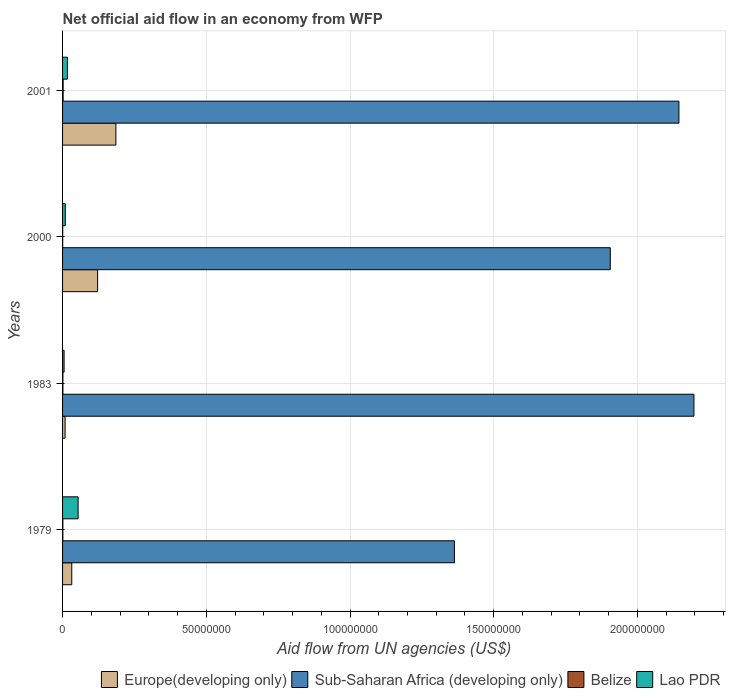How many different coloured bars are there?
Your response must be concise. 4. How many bars are there on the 1st tick from the bottom?
Your answer should be very brief. 4. What is the label of the 3rd group of bars from the top?
Your answer should be very brief. 1983. In how many cases, is the number of bars for a given year not equal to the number of legend labels?
Your answer should be compact. 0. Across all years, what is the maximum net official aid flow in Lao PDR?
Your answer should be very brief. 5.41e+06. In which year was the net official aid flow in Europe(developing only) maximum?
Provide a short and direct response. 2001. What is the total net official aid flow in Sub-Saharan Africa (developing only) in the graph?
Give a very brief answer. 7.61e+08. What is the difference between the net official aid flow in Lao PDR in 1979 and the net official aid flow in Sub-Saharan Africa (developing only) in 2000?
Keep it short and to the point. -1.85e+08. What is the average net official aid flow in Belize per year?
Your answer should be compact. 1.18e+05. In the year 2000, what is the difference between the net official aid flow in Lao PDR and net official aid flow in Sub-Saharan Africa (developing only)?
Provide a succinct answer. -1.90e+08. In how many years, is the net official aid flow in Lao PDR greater than 60000000 US$?
Make the answer very short. 0. What is the ratio of the net official aid flow in Europe(developing only) in 1979 to that in 1983?
Your answer should be compact. 3.64. Is the net official aid flow in Europe(developing only) in 1979 less than that in 1983?
Offer a very short reply. No. Is the difference between the net official aid flow in Lao PDR in 1979 and 2001 greater than the difference between the net official aid flow in Sub-Saharan Africa (developing only) in 1979 and 2001?
Offer a very short reply. Yes. What is the difference between the highest and the second highest net official aid flow in Belize?
Offer a terse response. 8.00e+04. What is the difference between the highest and the lowest net official aid flow in Lao PDR?
Keep it short and to the point. 4.88e+06. In how many years, is the net official aid flow in Belize greater than the average net official aid flow in Belize taken over all years?
Provide a short and direct response. 2. What does the 1st bar from the top in 1983 represents?
Your response must be concise. Lao PDR. What does the 1st bar from the bottom in 1979 represents?
Provide a succinct answer. Europe(developing only). How many bars are there?
Offer a very short reply. 16. Are all the bars in the graph horizontal?
Provide a succinct answer. Yes. What is the difference between two consecutive major ticks on the X-axis?
Make the answer very short. 5.00e+07. Does the graph contain any zero values?
Your response must be concise. No. Where does the legend appear in the graph?
Offer a terse response. Bottom right. What is the title of the graph?
Offer a terse response. Net official aid flow in an economy from WFP. What is the label or title of the X-axis?
Provide a short and direct response. Aid flow from UN agencies (US$). What is the label or title of the Y-axis?
Your answer should be very brief. Years. What is the Aid flow from UN agencies (US$) in Europe(developing only) in 1979?
Give a very brief answer. 3.20e+06. What is the Aid flow from UN agencies (US$) in Sub-Saharan Africa (developing only) in 1979?
Offer a terse response. 1.36e+08. What is the Aid flow from UN agencies (US$) of Lao PDR in 1979?
Your response must be concise. 5.41e+06. What is the Aid flow from UN agencies (US$) in Europe(developing only) in 1983?
Provide a succinct answer. 8.80e+05. What is the Aid flow from UN agencies (US$) of Sub-Saharan Africa (developing only) in 1983?
Provide a short and direct response. 2.20e+08. What is the Aid flow from UN agencies (US$) in Belize in 1983?
Give a very brief answer. 1.20e+05. What is the Aid flow from UN agencies (US$) of Lao PDR in 1983?
Ensure brevity in your answer.  5.30e+05. What is the Aid flow from UN agencies (US$) in Europe(developing only) in 2000?
Ensure brevity in your answer.  1.22e+07. What is the Aid flow from UN agencies (US$) in Sub-Saharan Africa (developing only) in 2000?
Your answer should be very brief. 1.91e+08. What is the Aid flow from UN agencies (US$) in Belize in 2000?
Provide a succinct answer. 5.00e+04. What is the Aid flow from UN agencies (US$) in Lao PDR in 2000?
Make the answer very short. 9.50e+05. What is the Aid flow from UN agencies (US$) of Europe(developing only) in 2001?
Make the answer very short. 1.86e+07. What is the Aid flow from UN agencies (US$) of Sub-Saharan Africa (developing only) in 2001?
Give a very brief answer. 2.14e+08. What is the Aid flow from UN agencies (US$) in Belize in 2001?
Provide a short and direct response. 2.00e+05. What is the Aid flow from UN agencies (US$) of Lao PDR in 2001?
Your answer should be very brief. 1.69e+06. Across all years, what is the maximum Aid flow from UN agencies (US$) of Europe(developing only)?
Keep it short and to the point. 1.86e+07. Across all years, what is the maximum Aid flow from UN agencies (US$) in Sub-Saharan Africa (developing only)?
Provide a short and direct response. 2.20e+08. Across all years, what is the maximum Aid flow from UN agencies (US$) of Lao PDR?
Your answer should be very brief. 5.41e+06. Across all years, what is the minimum Aid flow from UN agencies (US$) in Europe(developing only)?
Your response must be concise. 8.80e+05. Across all years, what is the minimum Aid flow from UN agencies (US$) in Sub-Saharan Africa (developing only)?
Your response must be concise. 1.36e+08. Across all years, what is the minimum Aid flow from UN agencies (US$) of Belize?
Keep it short and to the point. 5.00e+04. Across all years, what is the minimum Aid flow from UN agencies (US$) in Lao PDR?
Your response must be concise. 5.30e+05. What is the total Aid flow from UN agencies (US$) of Europe(developing only) in the graph?
Ensure brevity in your answer.  3.48e+07. What is the total Aid flow from UN agencies (US$) in Sub-Saharan Africa (developing only) in the graph?
Keep it short and to the point. 7.61e+08. What is the total Aid flow from UN agencies (US$) in Lao PDR in the graph?
Provide a short and direct response. 8.58e+06. What is the difference between the Aid flow from UN agencies (US$) in Europe(developing only) in 1979 and that in 1983?
Your response must be concise. 2.32e+06. What is the difference between the Aid flow from UN agencies (US$) in Sub-Saharan Africa (developing only) in 1979 and that in 1983?
Make the answer very short. -8.33e+07. What is the difference between the Aid flow from UN agencies (US$) in Belize in 1979 and that in 1983?
Your answer should be very brief. -2.00e+04. What is the difference between the Aid flow from UN agencies (US$) in Lao PDR in 1979 and that in 1983?
Provide a short and direct response. 4.88e+06. What is the difference between the Aid flow from UN agencies (US$) in Europe(developing only) in 1979 and that in 2000?
Provide a succinct answer. -8.99e+06. What is the difference between the Aid flow from UN agencies (US$) of Sub-Saharan Africa (developing only) in 1979 and that in 2000?
Provide a short and direct response. -5.42e+07. What is the difference between the Aid flow from UN agencies (US$) in Lao PDR in 1979 and that in 2000?
Provide a short and direct response. 4.46e+06. What is the difference between the Aid flow from UN agencies (US$) in Europe(developing only) in 1979 and that in 2001?
Your response must be concise. -1.54e+07. What is the difference between the Aid flow from UN agencies (US$) of Sub-Saharan Africa (developing only) in 1979 and that in 2001?
Your answer should be very brief. -7.81e+07. What is the difference between the Aid flow from UN agencies (US$) in Belize in 1979 and that in 2001?
Your answer should be very brief. -1.00e+05. What is the difference between the Aid flow from UN agencies (US$) in Lao PDR in 1979 and that in 2001?
Keep it short and to the point. 3.72e+06. What is the difference between the Aid flow from UN agencies (US$) in Europe(developing only) in 1983 and that in 2000?
Provide a succinct answer. -1.13e+07. What is the difference between the Aid flow from UN agencies (US$) of Sub-Saharan Africa (developing only) in 1983 and that in 2000?
Ensure brevity in your answer.  2.91e+07. What is the difference between the Aid flow from UN agencies (US$) of Lao PDR in 1983 and that in 2000?
Your answer should be very brief. -4.20e+05. What is the difference between the Aid flow from UN agencies (US$) of Europe(developing only) in 1983 and that in 2001?
Your answer should be compact. -1.77e+07. What is the difference between the Aid flow from UN agencies (US$) of Sub-Saharan Africa (developing only) in 1983 and that in 2001?
Give a very brief answer. 5.22e+06. What is the difference between the Aid flow from UN agencies (US$) of Lao PDR in 1983 and that in 2001?
Provide a succinct answer. -1.16e+06. What is the difference between the Aid flow from UN agencies (US$) of Europe(developing only) in 2000 and that in 2001?
Your response must be concise. -6.36e+06. What is the difference between the Aid flow from UN agencies (US$) in Sub-Saharan Africa (developing only) in 2000 and that in 2001?
Your answer should be very brief. -2.39e+07. What is the difference between the Aid flow from UN agencies (US$) in Lao PDR in 2000 and that in 2001?
Provide a short and direct response. -7.40e+05. What is the difference between the Aid flow from UN agencies (US$) in Europe(developing only) in 1979 and the Aid flow from UN agencies (US$) in Sub-Saharan Africa (developing only) in 1983?
Your response must be concise. -2.16e+08. What is the difference between the Aid flow from UN agencies (US$) of Europe(developing only) in 1979 and the Aid flow from UN agencies (US$) of Belize in 1983?
Keep it short and to the point. 3.08e+06. What is the difference between the Aid flow from UN agencies (US$) in Europe(developing only) in 1979 and the Aid flow from UN agencies (US$) in Lao PDR in 1983?
Give a very brief answer. 2.67e+06. What is the difference between the Aid flow from UN agencies (US$) of Sub-Saharan Africa (developing only) in 1979 and the Aid flow from UN agencies (US$) of Belize in 1983?
Provide a succinct answer. 1.36e+08. What is the difference between the Aid flow from UN agencies (US$) of Sub-Saharan Africa (developing only) in 1979 and the Aid flow from UN agencies (US$) of Lao PDR in 1983?
Your answer should be very brief. 1.36e+08. What is the difference between the Aid flow from UN agencies (US$) of Belize in 1979 and the Aid flow from UN agencies (US$) of Lao PDR in 1983?
Your answer should be compact. -4.30e+05. What is the difference between the Aid flow from UN agencies (US$) of Europe(developing only) in 1979 and the Aid flow from UN agencies (US$) of Sub-Saharan Africa (developing only) in 2000?
Ensure brevity in your answer.  -1.87e+08. What is the difference between the Aid flow from UN agencies (US$) in Europe(developing only) in 1979 and the Aid flow from UN agencies (US$) in Belize in 2000?
Offer a very short reply. 3.15e+06. What is the difference between the Aid flow from UN agencies (US$) in Europe(developing only) in 1979 and the Aid flow from UN agencies (US$) in Lao PDR in 2000?
Your response must be concise. 2.25e+06. What is the difference between the Aid flow from UN agencies (US$) in Sub-Saharan Africa (developing only) in 1979 and the Aid flow from UN agencies (US$) in Belize in 2000?
Give a very brief answer. 1.36e+08. What is the difference between the Aid flow from UN agencies (US$) of Sub-Saharan Africa (developing only) in 1979 and the Aid flow from UN agencies (US$) of Lao PDR in 2000?
Your response must be concise. 1.35e+08. What is the difference between the Aid flow from UN agencies (US$) of Belize in 1979 and the Aid flow from UN agencies (US$) of Lao PDR in 2000?
Offer a very short reply. -8.50e+05. What is the difference between the Aid flow from UN agencies (US$) of Europe(developing only) in 1979 and the Aid flow from UN agencies (US$) of Sub-Saharan Africa (developing only) in 2001?
Offer a very short reply. -2.11e+08. What is the difference between the Aid flow from UN agencies (US$) of Europe(developing only) in 1979 and the Aid flow from UN agencies (US$) of Lao PDR in 2001?
Your answer should be very brief. 1.51e+06. What is the difference between the Aid flow from UN agencies (US$) in Sub-Saharan Africa (developing only) in 1979 and the Aid flow from UN agencies (US$) in Belize in 2001?
Provide a short and direct response. 1.36e+08. What is the difference between the Aid flow from UN agencies (US$) in Sub-Saharan Africa (developing only) in 1979 and the Aid flow from UN agencies (US$) in Lao PDR in 2001?
Ensure brevity in your answer.  1.35e+08. What is the difference between the Aid flow from UN agencies (US$) of Belize in 1979 and the Aid flow from UN agencies (US$) of Lao PDR in 2001?
Your answer should be very brief. -1.59e+06. What is the difference between the Aid flow from UN agencies (US$) in Europe(developing only) in 1983 and the Aid flow from UN agencies (US$) in Sub-Saharan Africa (developing only) in 2000?
Make the answer very short. -1.90e+08. What is the difference between the Aid flow from UN agencies (US$) in Europe(developing only) in 1983 and the Aid flow from UN agencies (US$) in Belize in 2000?
Make the answer very short. 8.30e+05. What is the difference between the Aid flow from UN agencies (US$) in Europe(developing only) in 1983 and the Aid flow from UN agencies (US$) in Lao PDR in 2000?
Your answer should be compact. -7.00e+04. What is the difference between the Aid flow from UN agencies (US$) in Sub-Saharan Africa (developing only) in 1983 and the Aid flow from UN agencies (US$) in Belize in 2000?
Your answer should be very brief. 2.20e+08. What is the difference between the Aid flow from UN agencies (US$) of Sub-Saharan Africa (developing only) in 1983 and the Aid flow from UN agencies (US$) of Lao PDR in 2000?
Your answer should be compact. 2.19e+08. What is the difference between the Aid flow from UN agencies (US$) of Belize in 1983 and the Aid flow from UN agencies (US$) of Lao PDR in 2000?
Offer a very short reply. -8.30e+05. What is the difference between the Aid flow from UN agencies (US$) in Europe(developing only) in 1983 and the Aid flow from UN agencies (US$) in Sub-Saharan Africa (developing only) in 2001?
Make the answer very short. -2.14e+08. What is the difference between the Aid flow from UN agencies (US$) of Europe(developing only) in 1983 and the Aid flow from UN agencies (US$) of Belize in 2001?
Keep it short and to the point. 6.80e+05. What is the difference between the Aid flow from UN agencies (US$) in Europe(developing only) in 1983 and the Aid flow from UN agencies (US$) in Lao PDR in 2001?
Provide a short and direct response. -8.10e+05. What is the difference between the Aid flow from UN agencies (US$) in Sub-Saharan Africa (developing only) in 1983 and the Aid flow from UN agencies (US$) in Belize in 2001?
Provide a succinct answer. 2.19e+08. What is the difference between the Aid flow from UN agencies (US$) in Sub-Saharan Africa (developing only) in 1983 and the Aid flow from UN agencies (US$) in Lao PDR in 2001?
Offer a terse response. 2.18e+08. What is the difference between the Aid flow from UN agencies (US$) of Belize in 1983 and the Aid flow from UN agencies (US$) of Lao PDR in 2001?
Provide a succinct answer. -1.57e+06. What is the difference between the Aid flow from UN agencies (US$) in Europe(developing only) in 2000 and the Aid flow from UN agencies (US$) in Sub-Saharan Africa (developing only) in 2001?
Provide a short and direct response. -2.02e+08. What is the difference between the Aid flow from UN agencies (US$) of Europe(developing only) in 2000 and the Aid flow from UN agencies (US$) of Belize in 2001?
Your answer should be very brief. 1.20e+07. What is the difference between the Aid flow from UN agencies (US$) of Europe(developing only) in 2000 and the Aid flow from UN agencies (US$) of Lao PDR in 2001?
Keep it short and to the point. 1.05e+07. What is the difference between the Aid flow from UN agencies (US$) of Sub-Saharan Africa (developing only) in 2000 and the Aid flow from UN agencies (US$) of Belize in 2001?
Provide a succinct answer. 1.90e+08. What is the difference between the Aid flow from UN agencies (US$) in Sub-Saharan Africa (developing only) in 2000 and the Aid flow from UN agencies (US$) in Lao PDR in 2001?
Make the answer very short. 1.89e+08. What is the difference between the Aid flow from UN agencies (US$) of Belize in 2000 and the Aid flow from UN agencies (US$) of Lao PDR in 2001?
Ensure brevity in your answer.  -1.64e+06. What is the average Aid flow from UN agencies (US$) of Europe(developing only) per year?
Provide a succinct answer. 8.70e+06. What is the average Aid flow from UN agencies (US$) in Sub-Saharan Africa (developing only) per year?
Ensure brevity in your answer.  1.90e+08. What is the average Aid flow from UN agencies (US$) of Belize per year?
Your response must be concise. 1.18e+05. What is the average Aid flow from UN agencies (US$) in Lao PDR per year?
Provide a succinct answer. 2.14e+06. In the year 1979, what is the difference between the Aid flow from UN agencies (US$) in Europe(developing only) and Aid flow from UN agencies (US$) in Sub-Saharan Africa (developing only)?
Give a very brief answer. -1.33e+08. In the year 1979, what is the difference between the Aid flow from UN agencies (US$) of Europe(developing only) and Aid flow from UN agencies (US$) of Belize?
Give a very brief answer. 3.10e+06. In the year 1979, what is the difference between the Aid flow from UN agencies (US$) in Europe(developing only) and Aid flow from UN agencies (US$) in Lao PDR?
Offer a terse response. -2.21e+06. In the year 1979, what is the difference between the Aid flow from UN agencies (US$) in Sub-Saharan Africa (developing only) and Aid flow from UN agencies (US$) in Belize?
Provide a short and direct response. 1.36e+08. In the year 1979, what is the difference between the Aid flow from UN agencies (US$) in Sub-Saharan Africa (developing only) and Aid flow from UN agencies (US$) in Lao PDR?
Offer a very short reply. 1.31e+08. In the year 1979, what is the difference between the Aid flow from UN agencies (US$) of Belize and Aid flow from UN agencies (US$) of Lao PDR?
Provide a short and direct response. -5.31e+06. In the year 1983, what is the difference between the Aid flow from UN agencies (US$) of Europe(developing only) and Aid flow from UN agencies (US$) of Sub-Saharan Africa (developing only)?
Offer a terse response. -2.19e+08. In the year 1983, what is the difference between the Aid flow from UN agencies (US$) in Europe(developing only) and Aid flow from UN agencies (US$) in Belize?
Offer a very short reply. 7.60e+05. In the year 1983, what is the difference between the Aid flow from UN agencies (US$) in Europe(developing only) and Aid flow from UN agencies (US$) in Lao PDR?
Your answer should be very brief. 3.50e+05. In the year 1983, what is the difference between the Aid flow from UN agencies (US$) of Sub-Saharan Africa (developing only) and Aid flow from UN agencies (US$) of Belize?
Offer a very short reply. 2.20e+08. In the year 1983, what is the difference between the Aid flow from UN agencies (US$) in Sub-Saharan Africa (developing only) and Aid flow from UN agencies (US$) in Lao PDR?
Make the answer very short. 2.19e+08. In the year 1983, what is the difference between the Aid flow from UN agencies (US$) of Belize and Aid flow from UN agencies (US$) of Lao PDR?
Make the answer very short. -4.10e+05. In the year 2000, what is the difference between the Aid flow from UN agencies (US$) in Europe(developing only) and Aid flow from UN agencies (US$) in Sub-Saharan Africa (developing only)?
Ensure brevity in your answer.  -1.78e+08. In the year 2000, what is the difference between the Aid flow from UN agencies (US$) in Europe(developing only) and Aid flow from UN agencies (US$) in Belize?
Your response must be concise. 1.21e+07. In the year 2000, what is the difference between the Aid flow from UN agencies (US$) of Europe(developing only) and Aid flow from UN agencies (US$) of Lao PDR?
Your answer should be very brief. 1.12e+07. In the year 2000, what is the difference between the Aid flow from UN agencies (US$) of Sub-Saharan Africa (developing only) and Aid flow from UN agencies (US$) of Belize?
Provide a short and direct response. 1.90e+08. In the year 2000, what is the difference between the Aid flow from UN agencies (US$) in Sub-Saharan Africa (developing only) and Aid flow from UN agencies (US$) in Lao PDR?
Your answer should be very brief. 1.90e+08. In the year 2000, what is the difference between the Aid flow from UN agencies (US$) in Belize and Aid flow from UN agencies (US$) in Lao PDR?
Make the answer very short. -9.00e+05. In the year 2001, what is the difference between the Aid flow from UN agencies (US$) of Europe(developing only) and Aid flow from UN agencies (US$) of Sub-Saharan Africa (developing only)?
Give a very brief answer. -1.96e+08. In the year 2001, what is the difference between the Aid flow from UN agencies (US$) of Europe(developing only) and Aid flow from UN agencies (US$) of Belize?
Offer a terse response. 1.84e+07. In the year 2001, what is the difference between the Aid flow from UN agencies (US$) of Europe(developing only) and Aid flow from UN agencies (US$) of Lao PDR?
Offer a very short reply. 1.69e+07. In the year 2001, what is the difference between the Aid flow from UN agencies (US$) of Sub-Saharan Africa (developing only) and Aid flow from UN agencies (US$) of Belize?
Provide a short and direct response. 2.14e+08. In the year 2001, what is the difference between the Aid flow from UN agencies (US$) in Sub-Saharan Africa (developing only) and Aid flow from UN agencies (US$) in Lao PDR?
Keep it short and to the point. 2.13e+08. In the year 2001, what is the difference between the Aid flow from UN agencies (US$) in Belize and Aid flow from UN agencies (US$) in Lao PDR?
Provide a short and direct response. -1.49e+06. What is the ratio of the Aid flow from UN agencies (US$) of Europe(developing only) in 1979 to that in 1983?
Keep it short and to the point. 3.64. What is the ratio of the Aid flow from UN agencies (US$) in Sub-Saharan Africa (developing only) in 1979 to that in 1983?
Offer a very short reply. 0.62. What is the ratio of the Aid flow from UN agencies (US$) of Belize in 1979 to that in 1983?
Keep it short and to the point. 0.83. What is the ratio of the Aid flow from UN agencies (US$) of Lao PDR in 1979 to that in 1983?
Ensure brevity in your answer.  10.21. What is the ratio of the Aid flow from UN agencies (US$) in Europe(developing only) in 1979 to that in 2000?
Keep it short and to the point. 0.26. What is the ratio of the Aid flow from UN agencies (US$) of Sub-Saharan Africa (developing only) in 1979 to that in 2000?
Keep it short and to the point. 0.72. What is the ratio of the Aid flow from UN agencies (US$) in Belize in 1979 to that in 2000?
Provide a succinct answer. 2. What is the ratio of the Aid flow from UN agencies (US$) of Lao PDR in 1979 to that in 2000?
Offer a very short reply. 5.69. What is the ratio of the Aid flow from UN agencies (US$) of Europe(developing only) in 1979 to that in 2001?
Provide a succinct answer. 0.17. What is the ratio of the Aid flow from UN agencies (US$) of Sub-Saharan Africa (developing only) in 1979 to that in 2001?
Provide a succinct answer. 0.64. What is the ratio of the Aid flow from UN agencies (US$) in Belize in 1979 to that in 2001?
Your answer should be very brief. 0.5. What is the ratio of the Aid flow from UN agencies (US$) in Lao PDR in 1979 to that in 2001?
Provide a short and direct response. 3.2. What is the ratio of the Aid flow from UN agencies (US$) of Europe(developing only) in 1983 to that in 2000?
Ensure brevity in your answer.  0.07. What is the ratio of the Aid flow from UN agencies (US$) in Sub-Saharan Africa (developing only) in 1983 to that in 2000?
Ensure brevity in your answer.  1.15. What is the ratio of the Aid flow from UN agencies (US$) of Lao PDR in 1983 to that in 2000?
Give a very brief answer. 0.56. What is the ratio of the Aid flow from UN agencies (US$) of Europe(developing only) in 1983 to that in 2001?
Provide a short and direct response. 0.05. What is the ratio of the Aid flow from UN agencies (US$) of Sub-Saharan Africa (developing only) in 1983 to that in 2001?
Offer a very short reply. 1.02. What is the ratio of the Aid flow from UN agencies (US$) of Lao PDR in 1983 to that in 2001?
Your answer should be very brief. 0.31. What is the ratio of the Aid flow from UN agencies (US$) of Europe(developing only) in 2000 to that in 2001?
Provide a succinct answer. 0.66. What is the ratio of the Aid flow from UN agencies (US$) of Sub-Saharan Africa (developing only) in 2000 to that in 2001?
Your answer should be compact. 0.89. What is the ratio of the Aid flow from UN agencies (US$) in Belize in 2000 to that in 2001?
Offer a terse response. 0.25. What is the ratio of the Aid flow from UN agencies (US$) of Lao PDR in 2000 to that in 2001?
Offer a very short reply. 0.56. What is the difference between the highest and the second highest Aid flow from UN agencies (US$) in Europe(developing only)?
Provide a succinct answer. 6.36e+06. What is the difference between the highest and the second highest Aid flow from UN agencies (US$) of Sub-Saharan Africa (developing only)?
Your answer should be very brief. 5.22e+06. What is the difference between the highest and the second highest Aid flow from UN agencies (US$) of Belize?
Offer a terse response. 8.00e+04. What is the difference between the highest and the second highest Aid flow from UN agencies (US$) in Lao PDR?
Offer a very short reply. 3.72e+06. What is the difference between the highest and the lowest Aid flow from UN agencies (US$) in Europe(developing only)?
Ensure brevity in your answer.  1.77e+07. What is the difference between the highest and the lowest Aid flow from UN agencies (US$) in Sub-Saharan Africa (developing only)?
Make the answer very short. 8.33e+07. What is the difference between the highest and the lowest Aid flow from UN agencies (US$) in Lao PDR?
Offer a terse response. 4.88e+06. 